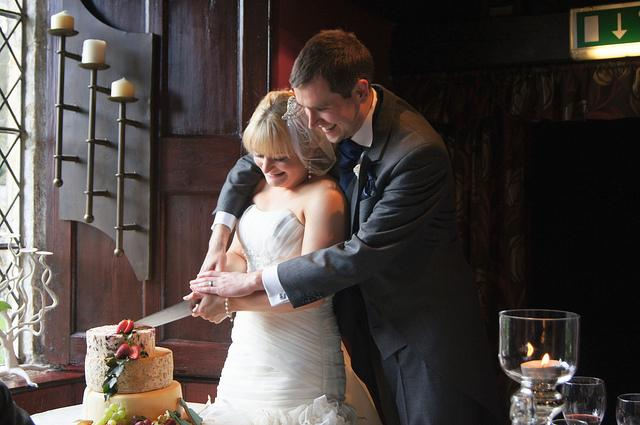What did the pair here recently exchange?

Choices:
A) clothes
B) moms
C) cards
D) rings rings 